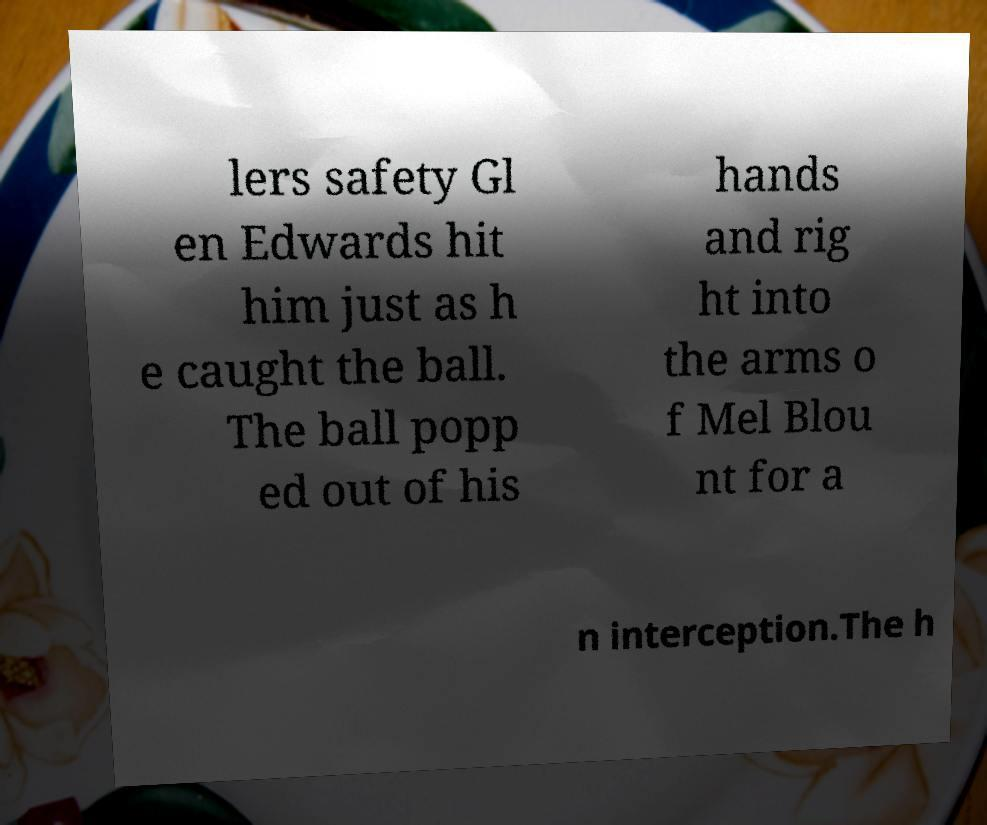I need the written content from this picture converted into text. Can you do that? lers safety Gl en Edwards hit him just as h e caught the ball. The ball popp ed out of his hands and rig ht into the arms o f Mel Blou nt for a n interception.The h 